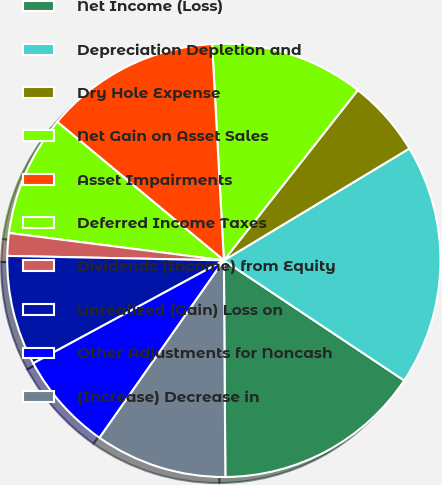Convert chart. <chart><loc_0><loc_0><loc_500><loc_500><pie_chart><fcel>Net Income (Loss)<fcel>Depreciation Depletion and<fcel>Dry Hole Expense<fcel>Net Gain on Asset Sales<fcel>Asset Impairments<fcel>Deferred Income Taxes<fcel>Dividends (Income) from Equity<fcel>Unrealized (Gain) Loss on<fcel>Other Adjustments for Noncash<fcel>(Increase) Decrease in<nl><fcel>15.54%<fcel>17.99%<fcel>5.76%<fcel>11.47%<fcel>13.1%<fcel>9.02%<fcel>1.69%<fcel>8.21%<fcel>7.39%<fcel>9.84%<nl></chart> 